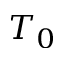Convert formula to latex. <formula><loc_0><loc_0><loc_500><loc_500>T _ { 0 }</formula> 